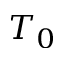Convert formula to latex. <formula><loc_0><loc_0><loc_500><loc_500>T _ { 0 }</formula> 